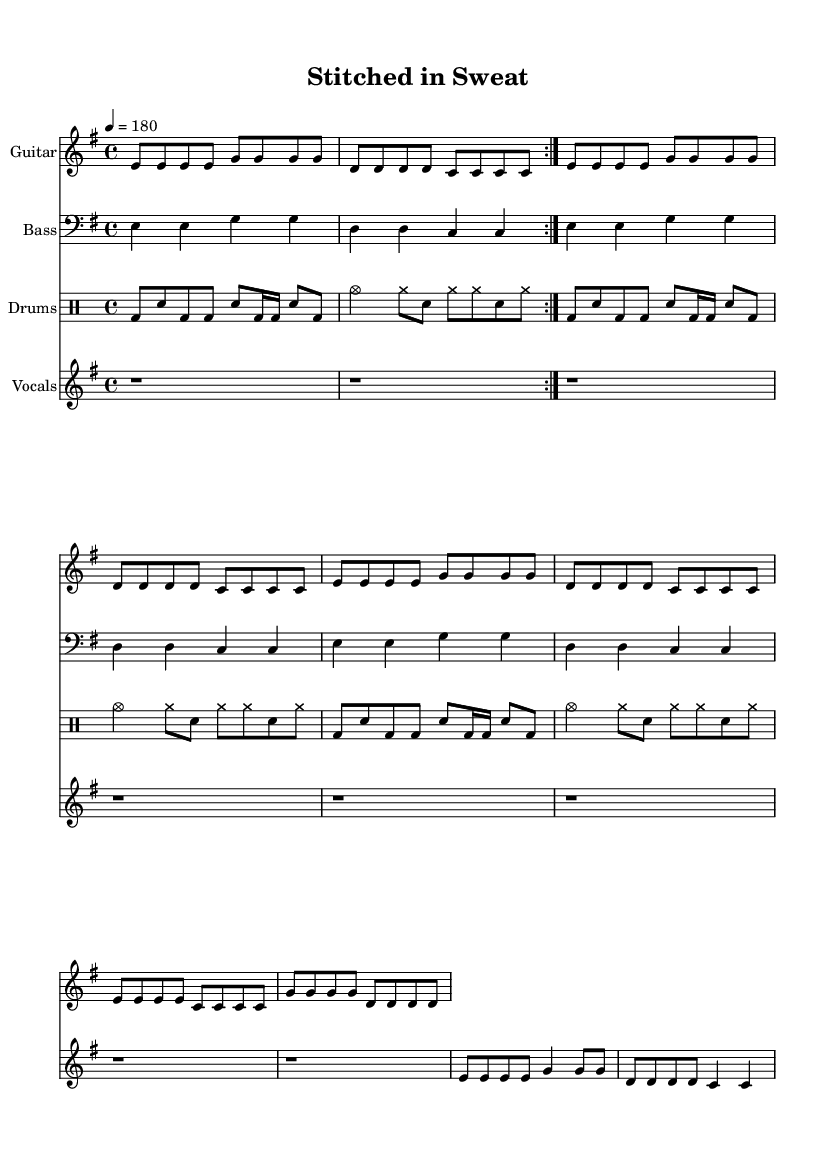What is the key signature of this music? The key signature indicated is E minor, which typically has one sharp (F#). We identify the key signature by examining the global settings defined at the top of the sheet music.
Answer: E minor What is the time signature of this music? The time signature shown is 4/4, meaning there are four beats in each measure and the quarter note gets one beat. This is evident from the global settings which also outline the time signature.
Answer: 4/4 What is the tempo marking of this piece? The tempo marking is set to 180 beats per minute, as stated in the global section. This indicates a fast pace typical of punk music.
Answer: 180 How many times is the guitar riff repeated? The guitar riff is repeated twice before moving onto the verse and chorus sections, as indicated by "repeat volta 2" next to the guitar riff in the score.
Answer: 2 What is the lyric in the chorus that reflects the struggles of textile workers? The lyric in the chorus is "Stitched in sweat, we toil all day," capturing the essence of labor and hardship faced by textile workers. The lyrics are aligned with the vocal melody in the staff.
Answer: Stitched in sweat, we toil all day What is the instrument playing the bass line? The instrument specified for the bass line is the Bass, which is clear from the instrument name given in the staff. The notes are written in the bass clef which is characteristic for bass instruments.
Answer: Bass What is the dynamic intensity suggested for the drums? The drumming pattern indicates a driving intensity typical of hardcore punk, characterized by aggressive beats shown in the drumming notation. This style is distinguished by loud play and fast patterns common in the genre.
Answer: Aggressive 